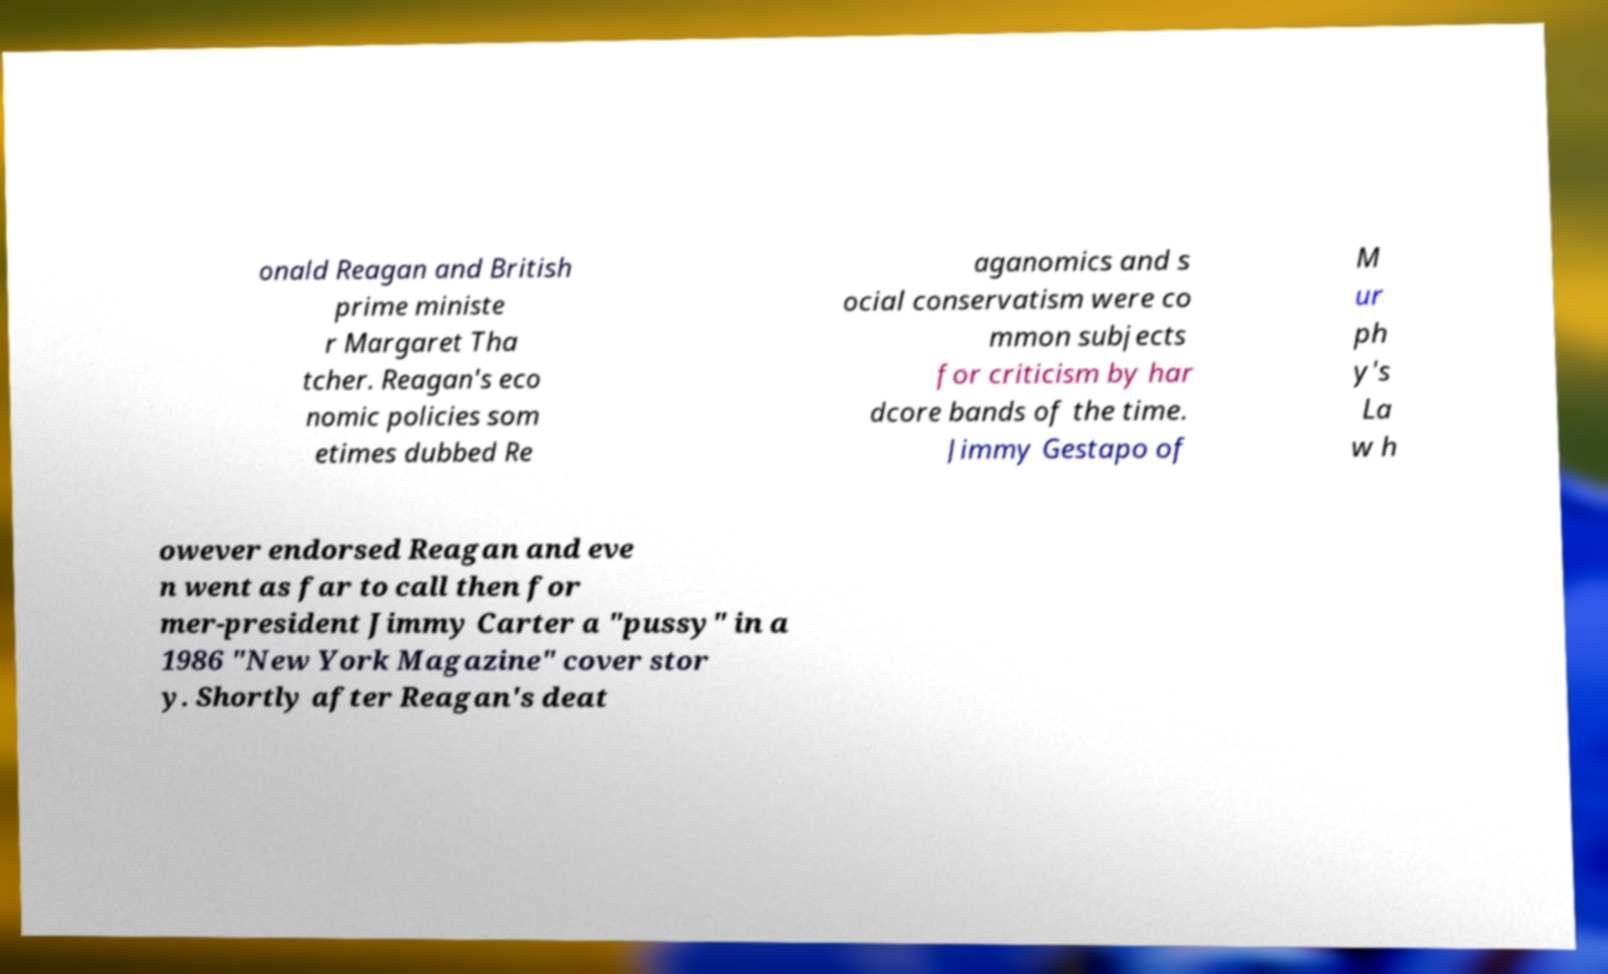Could you extract and type out the text from this image? onald Reagan and British prime ministe r Margaret Tha tcher. Reagan's eco nomic policies som etimes dubbed Re aganomics and s ocial conservatism were co mmon subjects for criticism by har dcore bands of the time. Jimmy Gestapo of M ur ph y's La w h owever endorsed Reagan and eve n went as far to call then for mer-president Jimmy Carter a "pussy" in a 1986 "New York Magazine" cover stor y. Shortly after Reagan's deat 